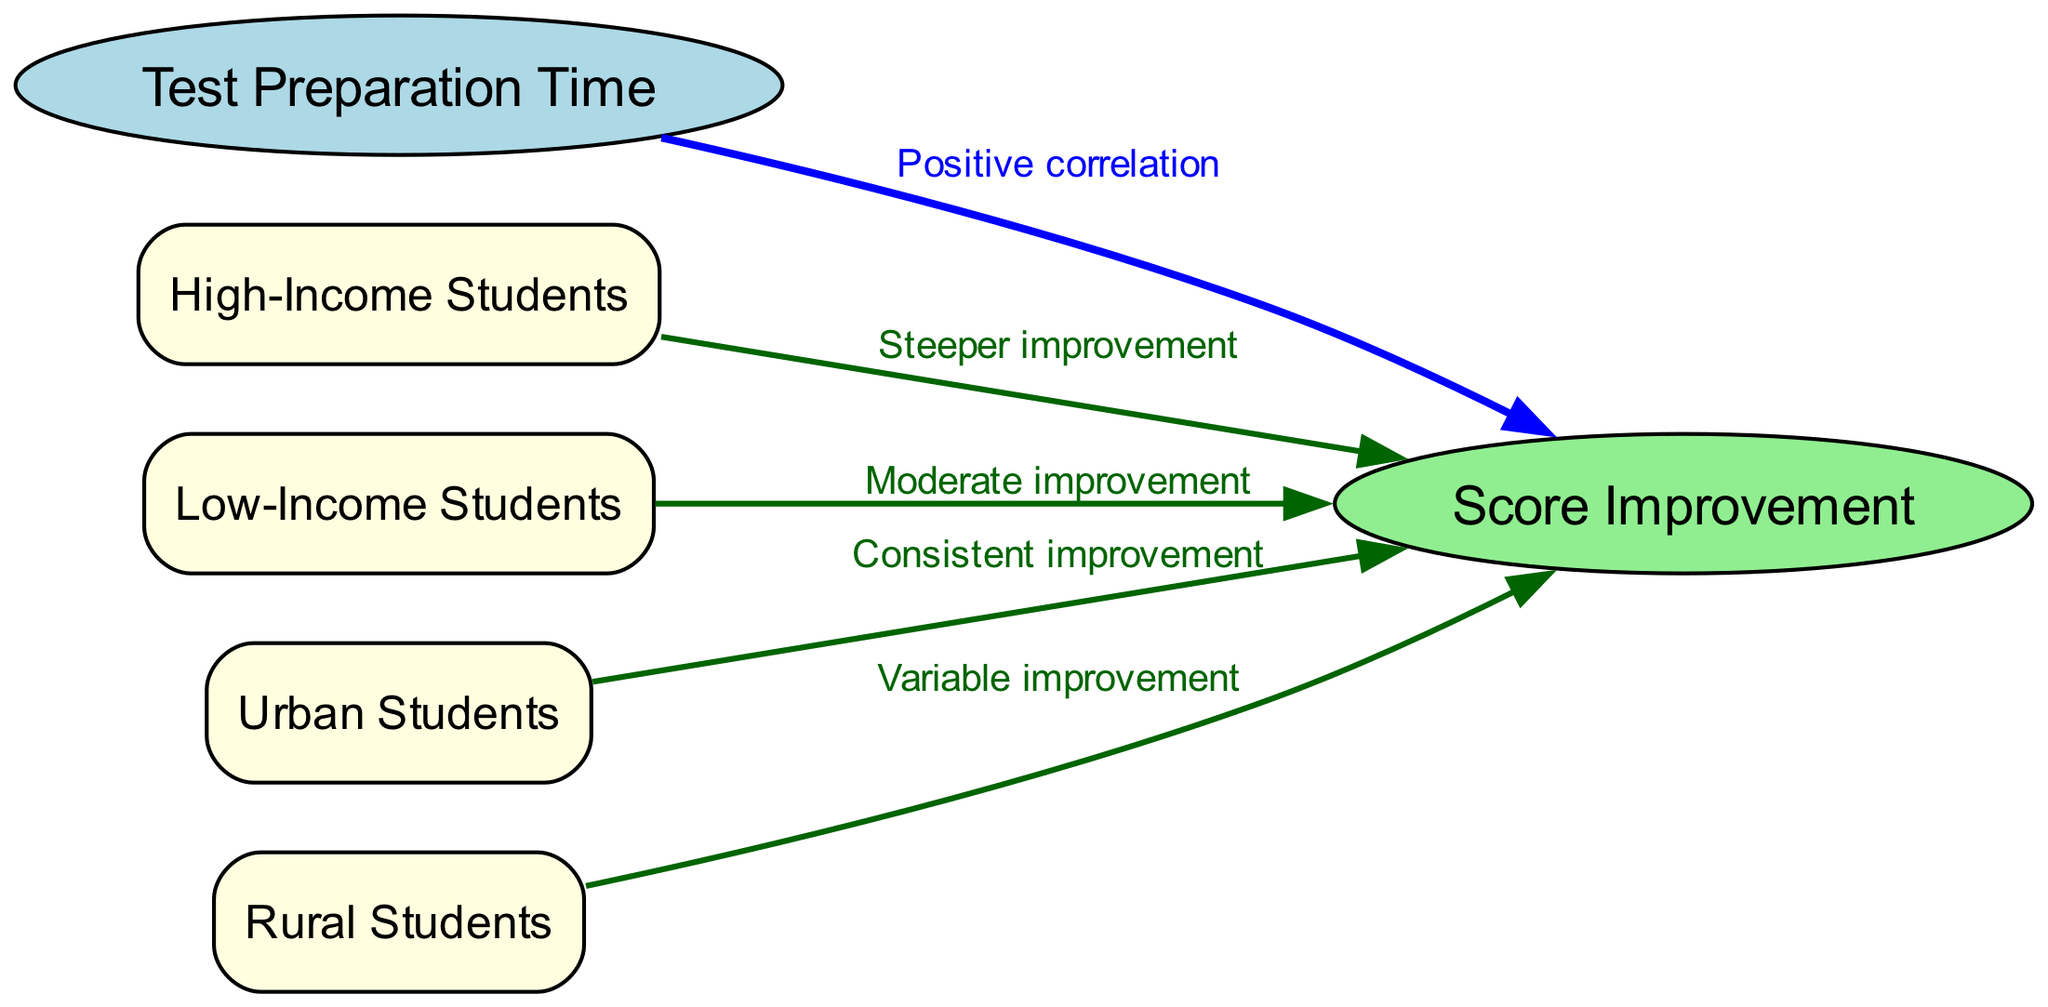What is the main focus of this diagram? The main focus of the diagram is to illustrate the relationship between test preparation time and score improvement for different demographic groups. This is evident from the central nodes labeled "Test Preparation Time" and "Score Improvement."
Answer: relationship between test preparation time and score improvement How many demographic groups are represented in the diagram? The diagram includes four demographic groups: High-Income Students, Low-Income Students, Urban Students, and Rural Students. By counting the nodes associated with demographic groups, we find a total of four groups represented.
Answer: four What type of correlation is shown between test preparation time and score improvement? The edge connecting "Test Preparation Time" and "Score Improvement" is labeled as "Positive correlation," indicating that as preparation time increases, score improvement is also likely to increase.
Answer: Positive correlation Which demographic group shows the steepest improvement in score with increased test preparation time? The edge from "High-Income Students" to "Score Improvement" is labeled "Steeper improvement," suggesting that this group benefits the most from increased preparation time compared to others.
Answer: High-Income Students What is the improvement type associated with Low-Income Students? The edge linking "Low-Income Students" to "Score Improvement" shows "Moderate improvement," indicating that this group experiences a lesser degree of improvement compared to the high-income group.
Answer: Moderate improvement How does Urban Students' improvement vary with test preparation time? The label on the edge from "Urban Students" to "Score Improvement" states "Consistent improvement," indicating that this group experiences a steady and reliable increase in scores with preparation time.
Answer: Consistent improvement Which demographic group experienced variable improvement in test scores? The edge directed from "Rural Students" to "Score Improvement" is labeled "Variable improvement," suggesting that this group may have more fluctuation in their improvement levels based on test preparation time.
Answer: Rural Students What does the diagram imply about the relationship between low test preparation time and score improvement for different demographic groups? The diagram suggests that while all demographic groups experience score improvements with increased preparation time, the extent and consistency of the improvement vary significantly, particularly highlighting the challenges faced by low-income and rural students with limited preparation time.
Answer: Variable improvement Which demographic group benefits the least from increasing test preparation time according to the diagram? Based on the labels, "Rural Students" show "Variable improvement," which implies inconsistency and potentially less benefit compared to higher-income or urban students, indicating they may not benefit as much overall.
Answer: Rural Students 